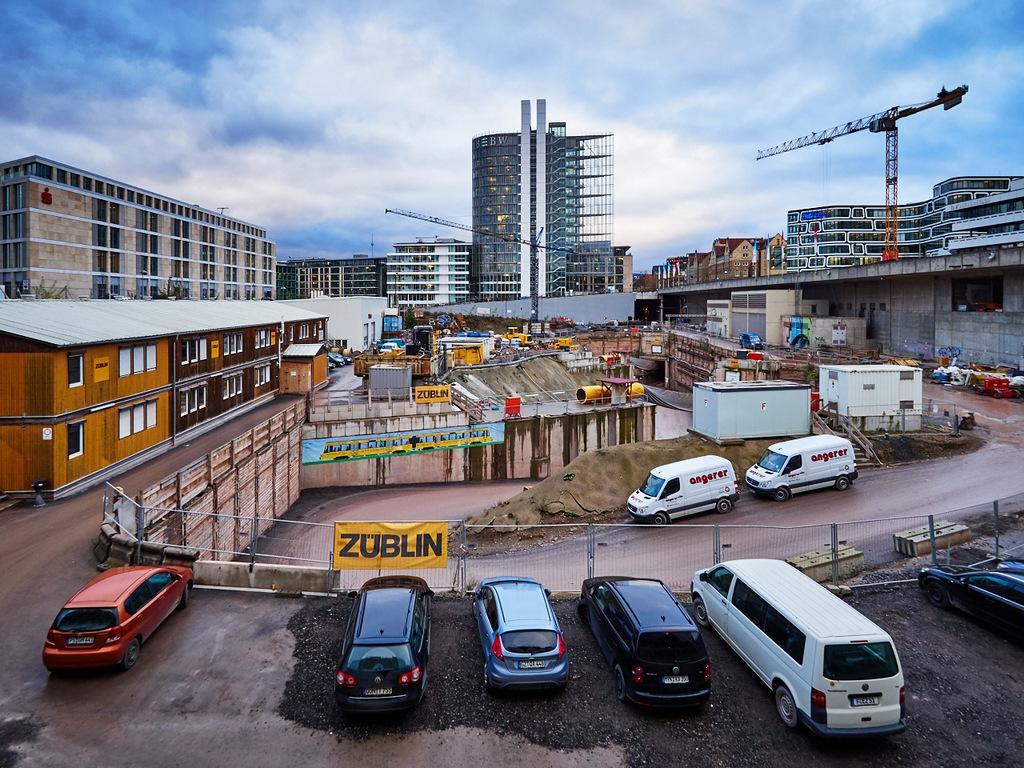In one or two sentences, can you explain what this image depicts? This is the picture of a city. In this image there are vehicles on the road. At the back there are buildings and there is a crane. At the top there is sky and there are clouds. At the bottom there is a road and there is mud. 